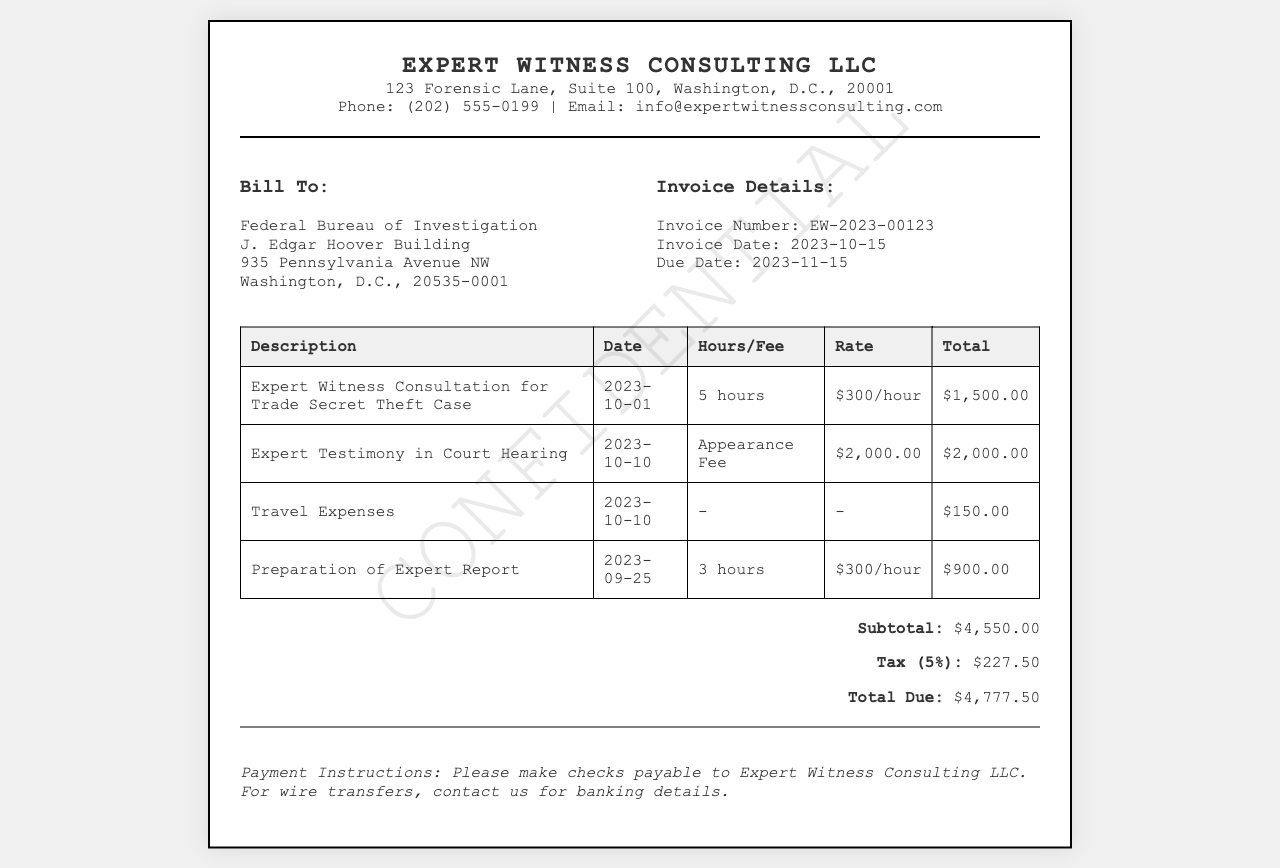What is the invoice number? The invoice number is listed in the invoice details section, which specifies "Invoice Number: EW-2023-00123."
Answer: EW-2023-00123 What is the total amount due? The total due is calculated at the bottom of the invoice, stated as "Total Due: $4,777.50."
Answer: $4,777.50 Who is the client billed in this invoice? The billed client is provided in the client info section, which states "Federal Bureau of Investigation."
Answer: Federal Bureau of Investigation What was the appearance fee? The appearance fee is found under specific charges, listed as "Appearance Fee" with a corresponding amount of "$2,000.00."
Answer: $2,000.00 On what date was the expert testimony provided? The date of the expert testimony is noted under the charge description, which indicates "Date: 2023-10-10."
Answer: 2023-10-10 How many hours of consultation were billed? The consultation hours are specified in the charge for the "Expert Witness Consultation," indicating "5 hours."
Answer: 5 hours What percentage tax was applied to the subtotal? The tax percentage is mentioned in the summary section, which specifies "Tax (5%)."
Answer: 5% What service incurred travel expenses? The travel expenses are listed as "Travel Expenses" with a specified amount of "$150.00."
Answer: Travel Expenses What is the due date for this invoice? The due date is provided in the invoice details, specified as "Due Date: 2023-11-15."
Answer: 2023-11-15 